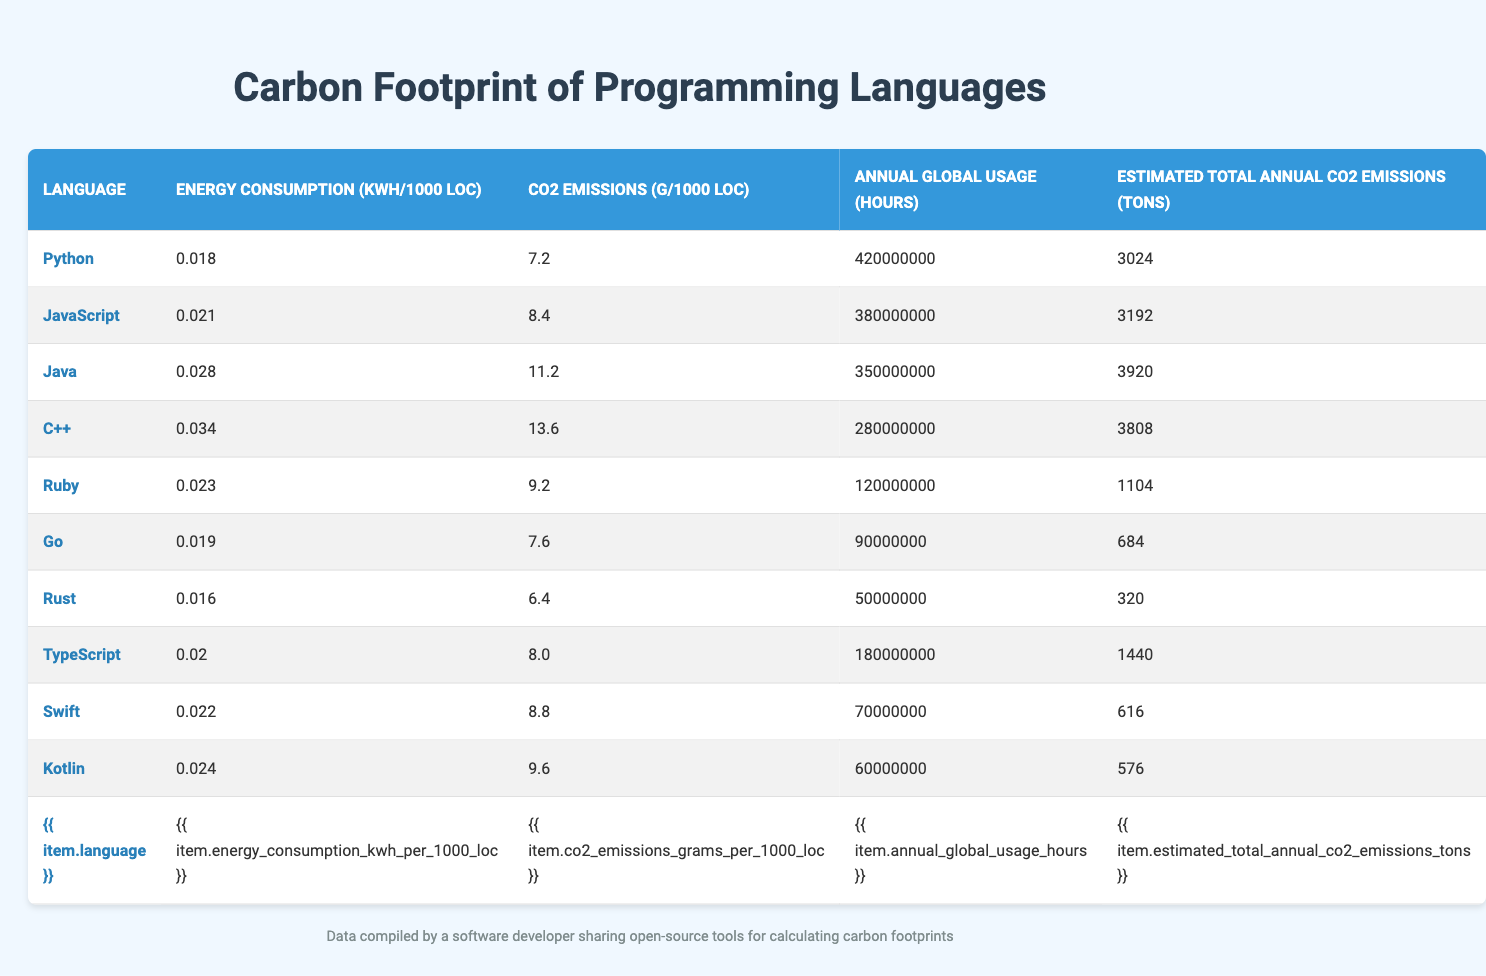What is the carbon emissions per 1000 lines of code for Python? According to the table, Python has a carbon emission value of 7.2 grams per 1000 lines of code.
Answer: 7.2 grams Which programming language has the highest estimated total annual CO2 emissions? The table indicates that Java has the highest estimated total annual CO2 emissions at 3920 tons.
Answer: Java How much energy does C++ consume per 1000 lines of code? The energy consumption for C++ is listed as 0.034 kWh per 1000 lines of code in the table.
Answer: 0.034 kWh What is the total annual CO2 emissions of TypeScript and Ruby combined? TypeScript has 1440 tons and Ruby has 1104 tons. Adding these gives 1440 + 1104 = 2544 tons, which is the combined total.
Answer: 2544 tons Which programming language consumes the least energy per 1000 lines of code? The table shows that Rust consumes 0.016 kWh per 1000 lines of code, which is the lowest among the listed languages.
Answer: Rust Is the energy consumption for Go higher than that for Python? The energy consumption for Go is 0.019 kWh while Python's is 0.018 kWh, so Go does consume more energy than Python.
Answer: Yes What is the average carbon emissions per 1000 lines of code for all languages presented? Adding the emissions: (7.2 + 8.4 + 11.2 + 13.6 + 9.2 + 7.6 + 6.4 + 8.0 + 8.8 + 9.6) = 80.0 grams; dividing by 10 languages gives 80.0 / 10 = 8.0 grams average emissions.
Answer: 8.0 grams Which language has lower CO2 emissions than 8 grams per 1000 lines of code? From the data, Python (7.2 g), Go (7.6 g), and Rust (6.4 g) all have emissions under 8 grams per 1000 lines of code.
Answer: Python, Go, Rust How many hours is JavaScript used globally in a year compared to Rust? JavaScript is used for 380,000,000 hours, while Rust is used for 50,000,000 hours, which shows a significant difference of 330,000,000 hours more for JavaScript.
Answer: 330,000,000 hours more Does Kotlin's estimated total annual CO2 emissions exceed that of Swift? Kotlin has 576 tons while Swift has 616 tons, indicating Kotlin does not exceed Swift in emissions.
Answer: No 